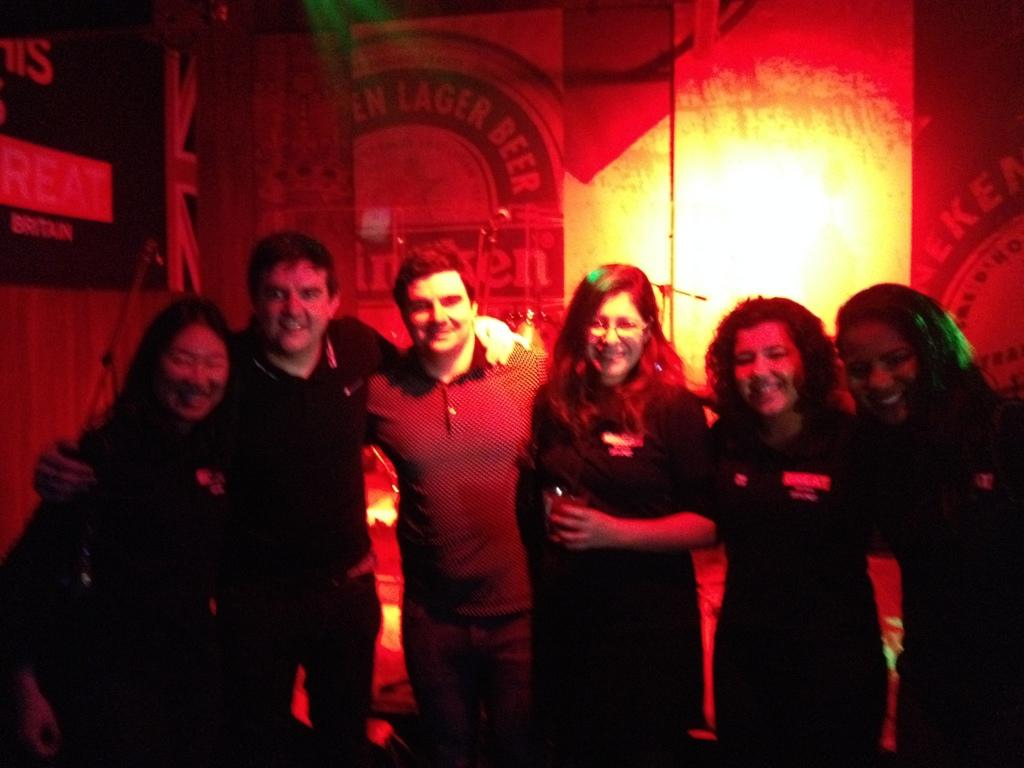How many people are in the image? There is a group of people in the image. What are the people doing in the image? The people are standing and smiling. What can be seen in the background of the image? There is a wall, lights, and other objects visible in the background of the image. What type of flag is being waved by the people in the image? There is no flag visible in the image; the people are simply standing and smiling. Can you tell me how many homes are present in the image? There is no home present in the image; it features a group of people standing and smiling in front of a wall and other objects. 